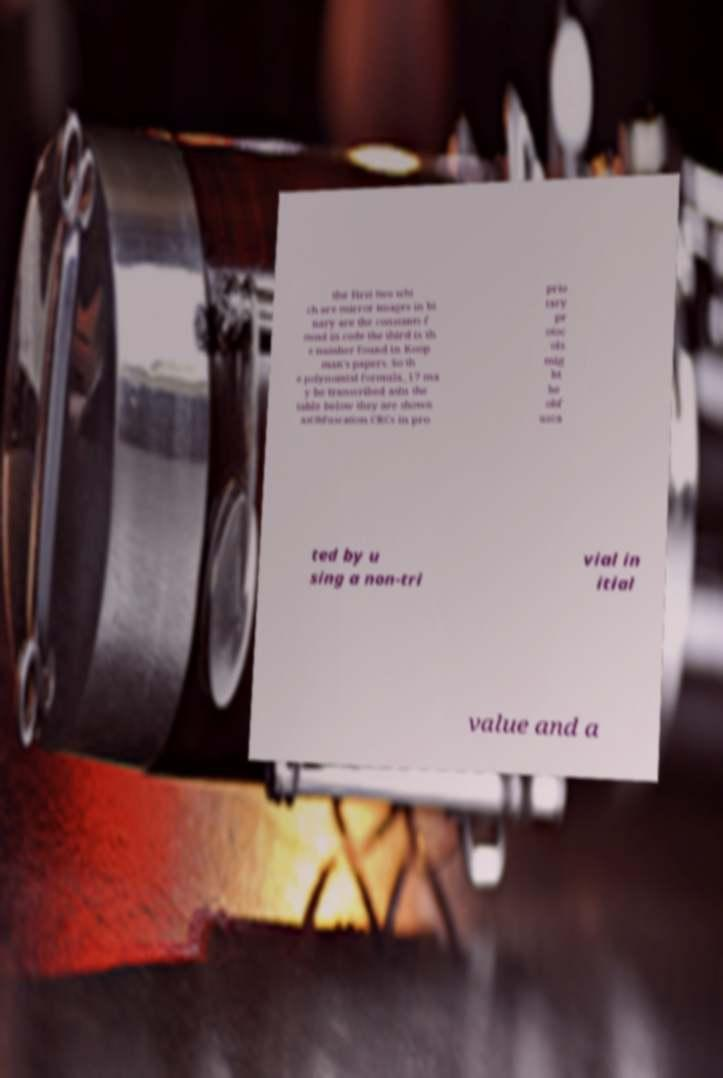What messages or text are displayed in this image? I need them in a readable, typed format. the first two whi ch are mirror images in bi nary are the constants f ound in code the third is th e number found in Koop man's papers. So th e polynomial formula_17 ma y be transcribed asIn the table below they are shown asObfuscation.CRCs in pro prie tary pr otoc ols mig ht be obf usca ted by u sing a non-tri vial in itial value and a 